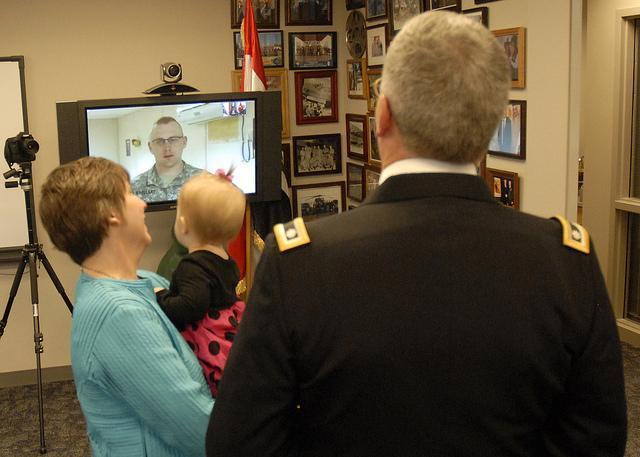How many people are in the photo?
Give a very brief answer. 4. How many cars are driving in the opposite direction of the street car?
Give a very brief answer. 0. 